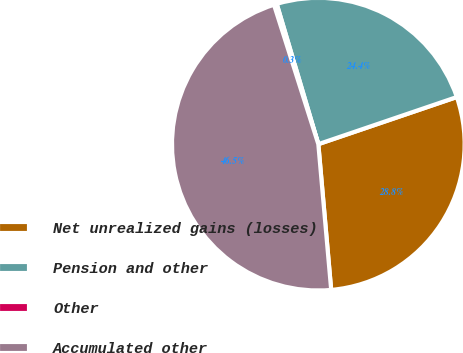Convert chart to OTSL. <chart><loc_0><loc_0><loc_500><loc_500><pie_chart><fcel>Net unrealized gains (losses)<fcel>Pension and other<fcel>Other<fcel>Accumulated other<nl><fcel>28.82%<fcel>24.37%<fcel>0.31%<fcel>46.5%<nl></chart> 